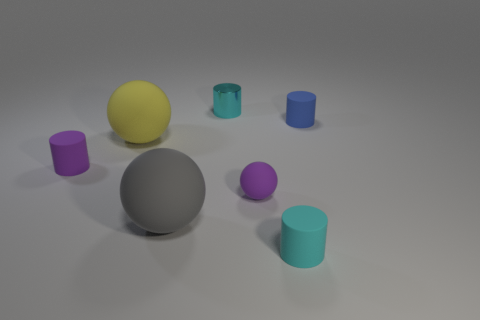Subtract all gray cylinders. Subtract all yellow blocks. How many cylinders are left? 4 Add 2 blue matte cylinders. How many objects exist? 9 Subtract all balls. How many objects are left? 4 Subtract 1 purple cylinders. How many objects are left? 6 Subtract all small cyan shiny cylinders. Subtract all objects. How many objects are left? 5 Add 7 big yellow things. How many big yellow things are left? 8 Add 4 small blue things. How many small blue things exist? 5 